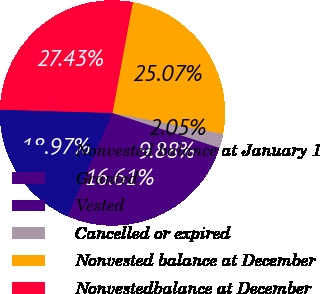Convert chart. <chart><loc_0><loc_0><loc_500><loc_500><pie_chart><fcel>Nonvested balance at January 1<fcel>Granted<fcel>Vested<fcel>Cancelled or expired<fcel>Nonvested balance at December<fcel>Nonvestedbalance at December<nl><fcel>18.97%<fcel>16.61%<fcel>9.88%<fcel>2.05%<fcel>25.07%<fcel>27.43%<nl></chart> 